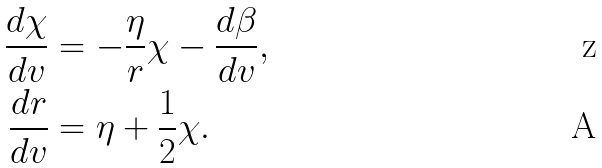<formula> <loc_0><loc_0><loc_500><loc_500>\frac { d \chi } { d v } & = - \frac { \eta } { r } \chi - \frac { d \beta } { d v } , \\ \frac { d r } { d v } & = \eta + \frac { 1 } { 2 } \chi .</formula> 